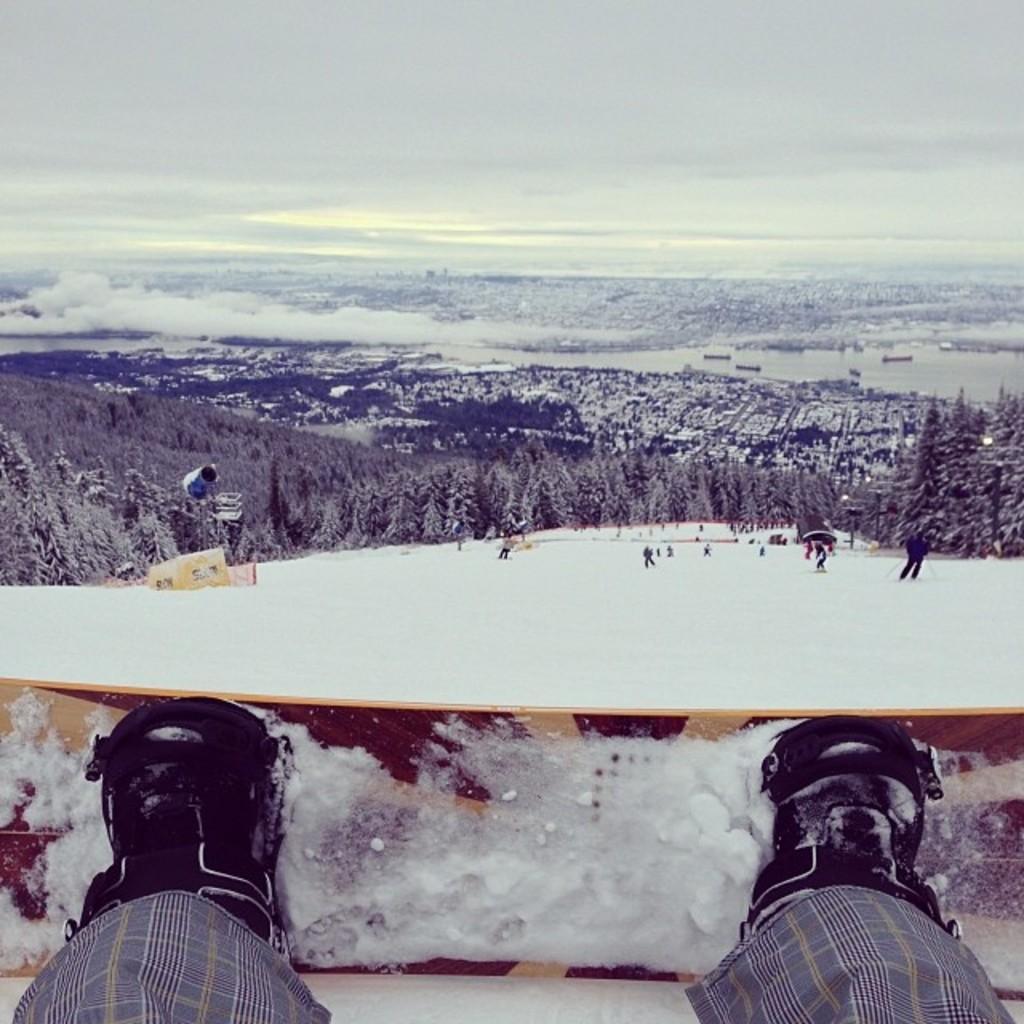Describe this image in one or two sentences. In this image there is a snow ground in which there are few people skiing. At the bottom there is a person standing on the ski-board. In the background there are snow mountains. On the right side there are trees which are covered with the snow. 